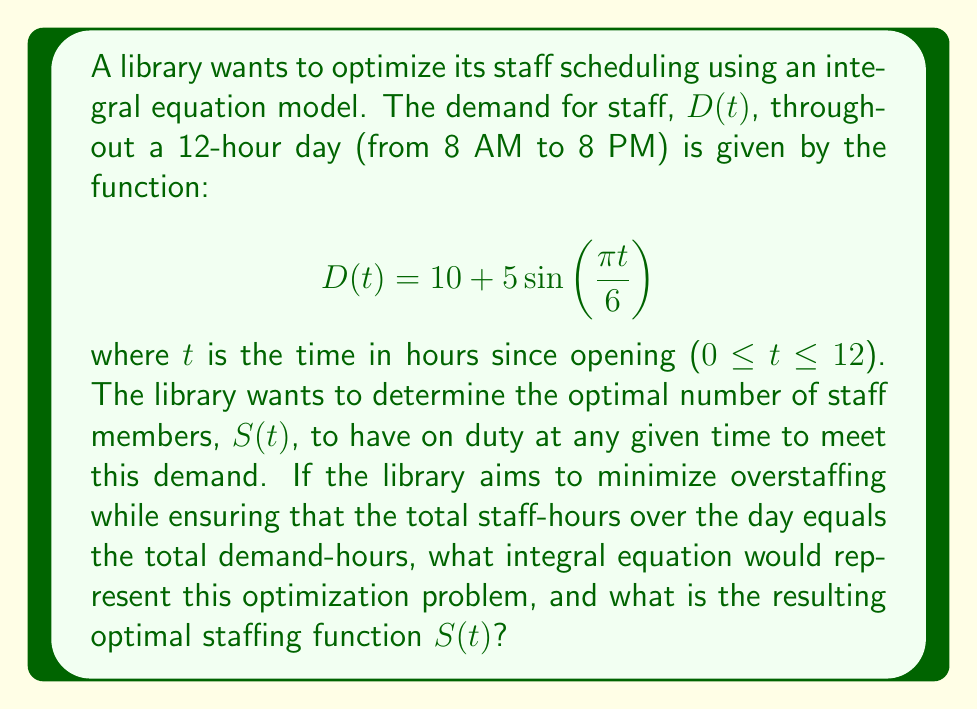Provide a solution to this math problem. Let's approach this step-by-step:

1) First, we need to set up an integral equation that represents the constraint that the total staff-hours should equal the total demand-hours:

   $$\int_0^{12} S(t) dt = \int_0^{12} D(t) dt$$

2) We know that $D(t) = 10 + 5\sin(\frac{\pi t}{6})$. Let's solve the right side of the equation:

   $$\int_0^{12} (10 + 5\sin(\frac{\pi t}{6})) dt = [10t - \frac{30}{\pi}\cos(\frac{\pi t}{6})]_0^{12}$$
   $$= (120 - \frac{30}{\pi}\cos(2\pi)) - (0 - \frac{30}{\pi}\cos(0))$$
   $$= 120 - \frac{30}{\pi} + \frac{30}{\pi} = 120$$

3) So our constraint equation becomes:

   $$\int_0^{12} S(t) dt = 120$$

4) To minimize overstaffing while meeting demand, the optimal staffing function $S(t)$ should follow the shape of $D(t)$, but scaled to satisfy the constraint. We can represent this as:

   $$S(t) = a + b\sin(\frac{\pi t}{6})$$

   where $a$ and $b$ are constants we need to determine.

5) Substituting this into our constraint equation:

   $$\int_0^{12} (a + b\sin(\frac{\pi t}{6})) dt = 120$$

6) Solving this integral:

   $$[at - \frac{6b}{\pi}\cos(\frac{\pi t}{6})]_0^{12} = 120$$
   $$12a = 120$$
   $$a = 10$$

7) Now, to determine $b$, we can use the fact that the amplitude of $S(t)$ should be proportional to the amplitude of $D(t)$. The amplitude of $D(t)$ is 5, so:

   $$\frac{b}{5} = \frac{10}{10}$$
   $$b = 5$$

8) Therefore, the optimal staffing function is:

   $$S(t) = 10 + 5\sin(\frac{\pi t}{6})$$

This function ensures that the total staff-hours equals the total demand-hours while following the same pattern as the demand function.
Answer: $S(t) = 10 + 5\sin(\frac{\pi t}{6})$ 